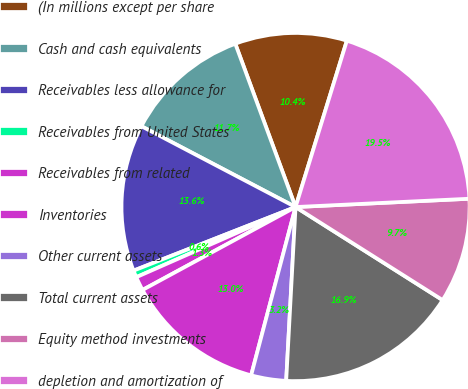<chart> <loc_0><loc_0><loc_500><loc_500><pie_chart><fcel>(In millions except per share<fcel>Cash and cash equivalents<fcel>Receivables less allowance for<fcel>Receivables from United States<fcel>Receivables from related<fcel>Inventories<fcel>Other current assets<fcel>Total current assets<fcel>Equity method investments<fcel>depletion and amortization of<nl><fcel>10.39%<fcel>11.69%<fcel>13.64%<fcel>0.65%<fcel>1.3%<fcel>12.99%<fcel>3.25%<fcel>16.88%<fcel>9.74%<fcel>19.48%<nl></chart> 